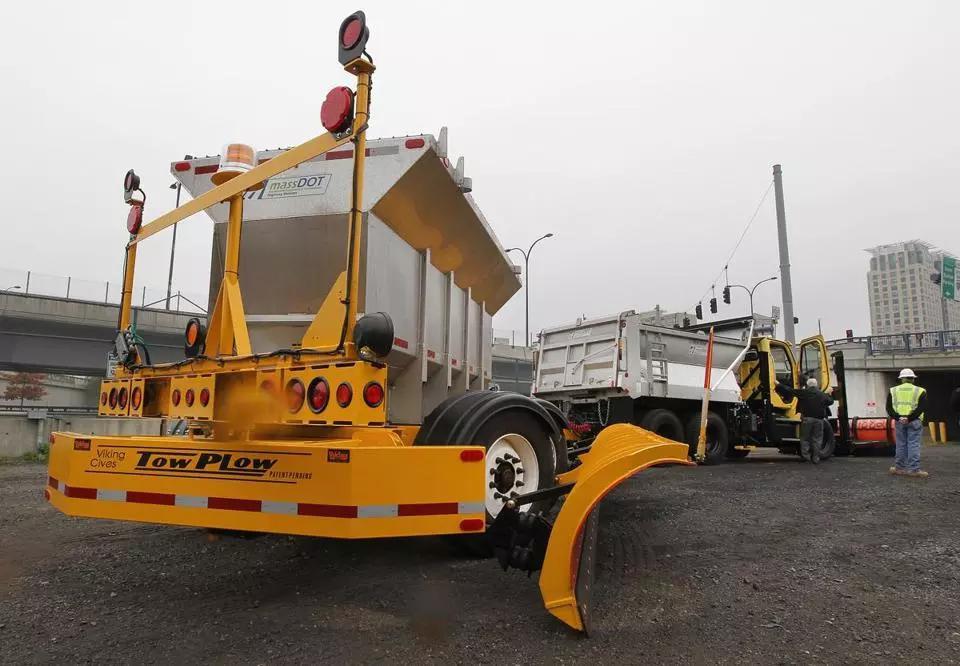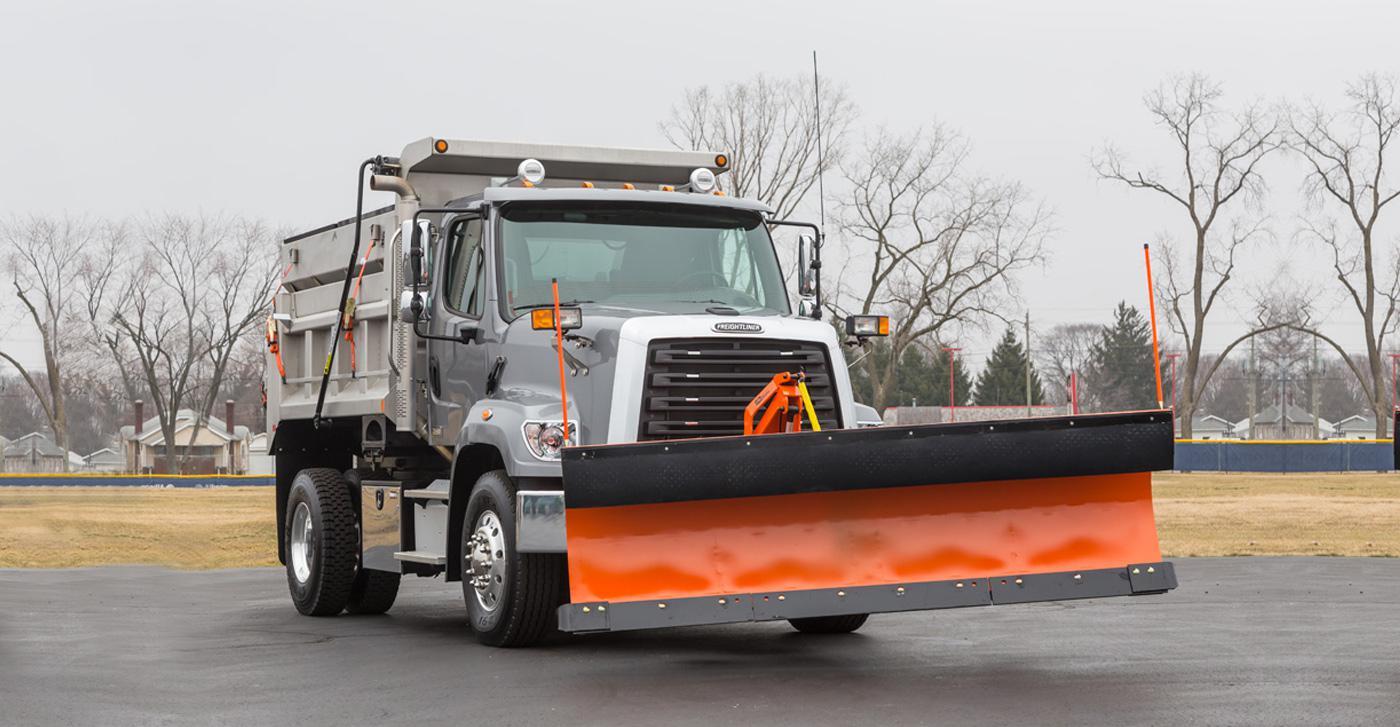The first image is the image on the left, the second image is the image on the right. Given the left and right images, does the statement "The image on the right contains an orange truck." hold true? Answer yes or no. No. 